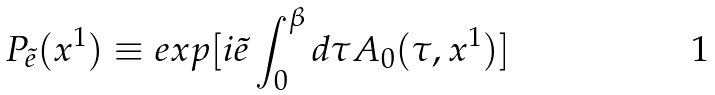<formula> <loc_0><loc_0><loc_500><loc_500>P _ { \tilde { e } } ( x ^ { 1 } ) \equiv e x p [ i \tilde { e } \int _ { 0 } ^ { \beta } d \tau A _ { 0 } ( \tau , x ^ { 1 } ) ]</formula> 